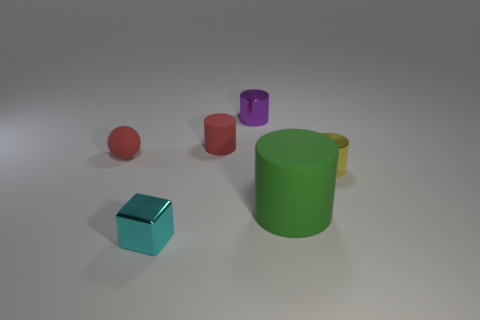There is a red cylinder; is its size the same as the cylinder that is on the right side of the green rubber object?
Ensure brevity in your answer.  Yes. What size is the matte cylinder in front of the small yellow object that is in front of the red object on the left side of the small cyan object?
Your answer should be very brief. Large. There is a large green rubber cylinder; how many things are in front of it?
Your answer should be very brief. 1. What material is the thing that is in front of the matte thing in front of the yellow metallic cylinder made of?
Ensure brevity in your answer.  Metal. Are there any other things that are the same size as the red ball?
Offer a very short reply. Yes. Is the cyan object the same size as the purple cylinder?
Your response must be concise. Yes. What number of objects are cylinders that are on the left side of the yellow cylinder or shiny cylinders that are to the left of the large matte object?
Provide a succinct answer. 3. Are there more tiny yellow shiny cylinders that are left of the tiny red cylinder than matte spheres?
Offer a very short reply. No. How many other things are the same shape as the big green object?
Make the answer very short. 3. What is the cylinder that is both behind the tiny yellow metal thing and in front of the purple metallic cylinder made of?
Keep it short and to the point. Rubber. 